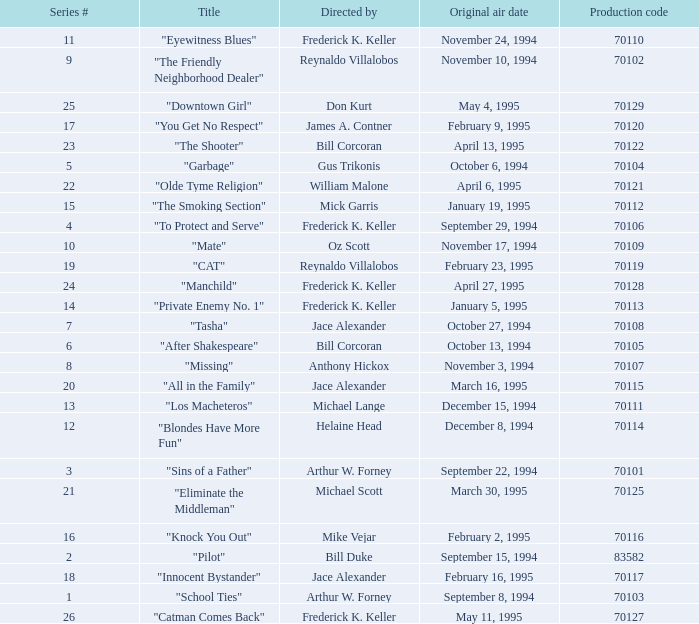What was the lowest production code value in series #10? 70109.0. 